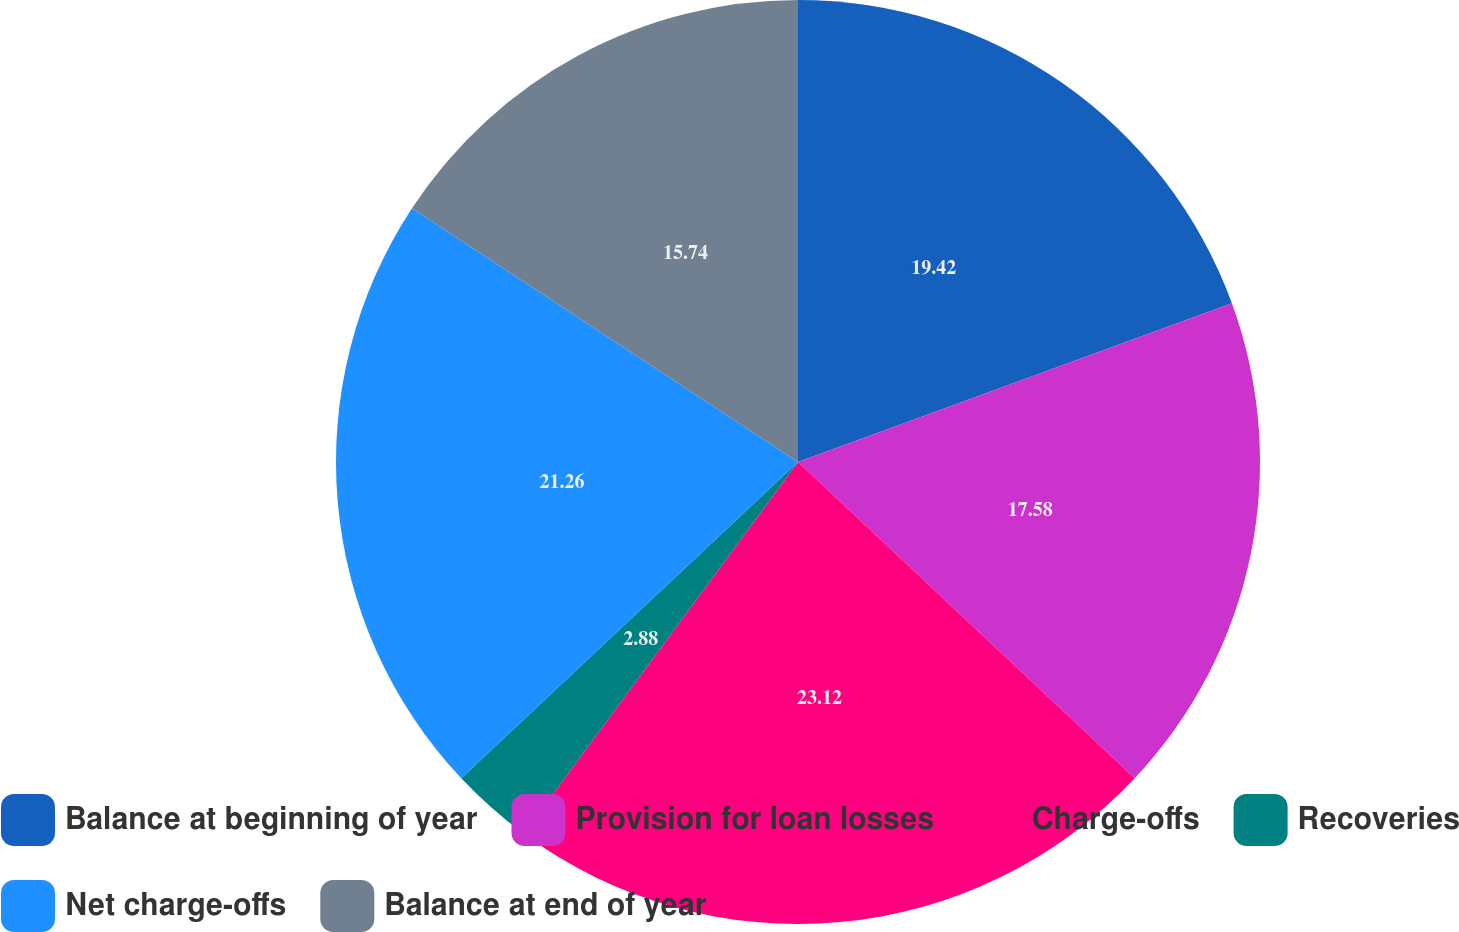Convert chart to OTSL. <chart><loc_0><loc_0><loc_500><loc_500><pie_chart><fcel>Balance at beginning of year<fcel>Provision for loan losses<fcel>Charge-offs<fcel>Recoveries<fcel>Net charge-offs<fcel>Balance at end of year<nl><fcel>19.42%<fcel>17.58%<fcel>23.11%<fcel>2.88%<fcel>21.26%<fcel>15.74%<nl></chart> 